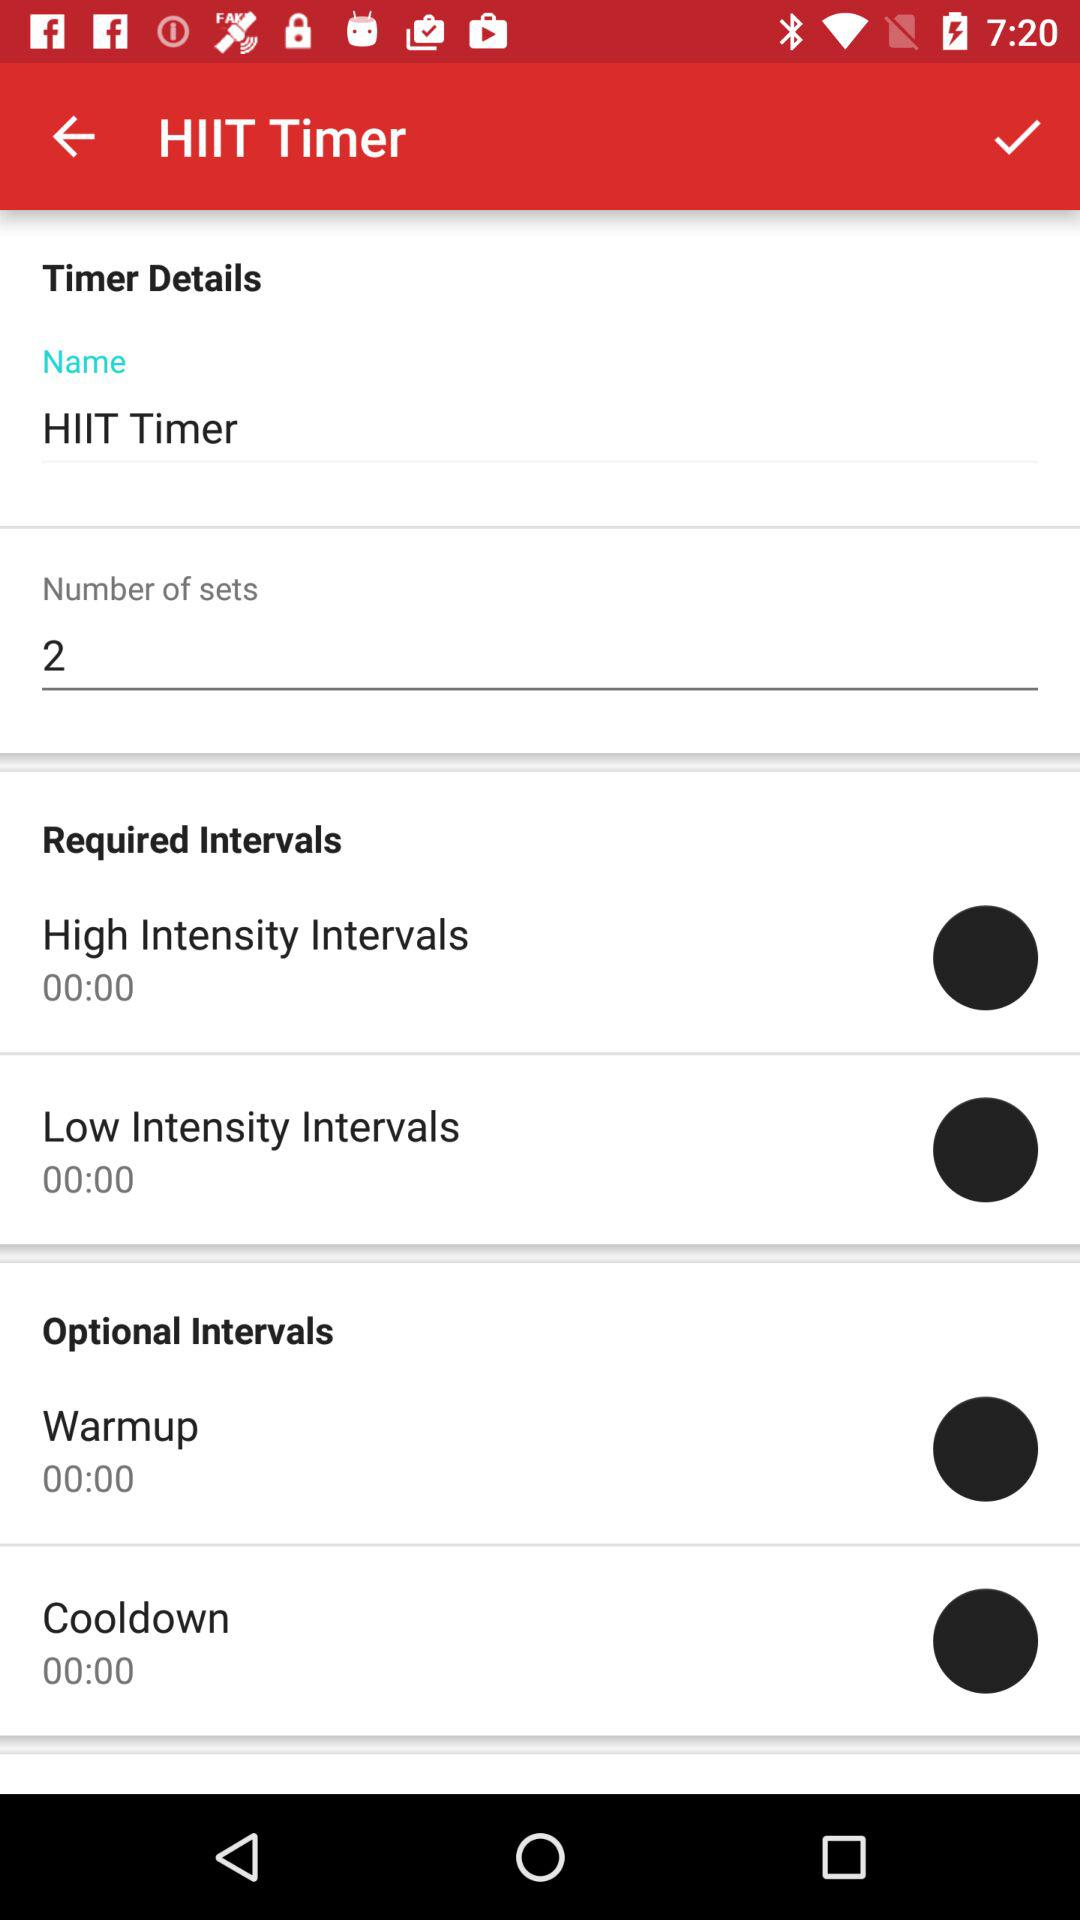How many optional intervals are there?
Answer the question using a single word or phrase. 2 